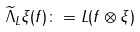<formula> <loc_0><loc_0><loc_500><loc_500>\widetilde { \Lambda } _ { L } \xi ( f ) \colon = L ( f \otimes \xi )</formula> 